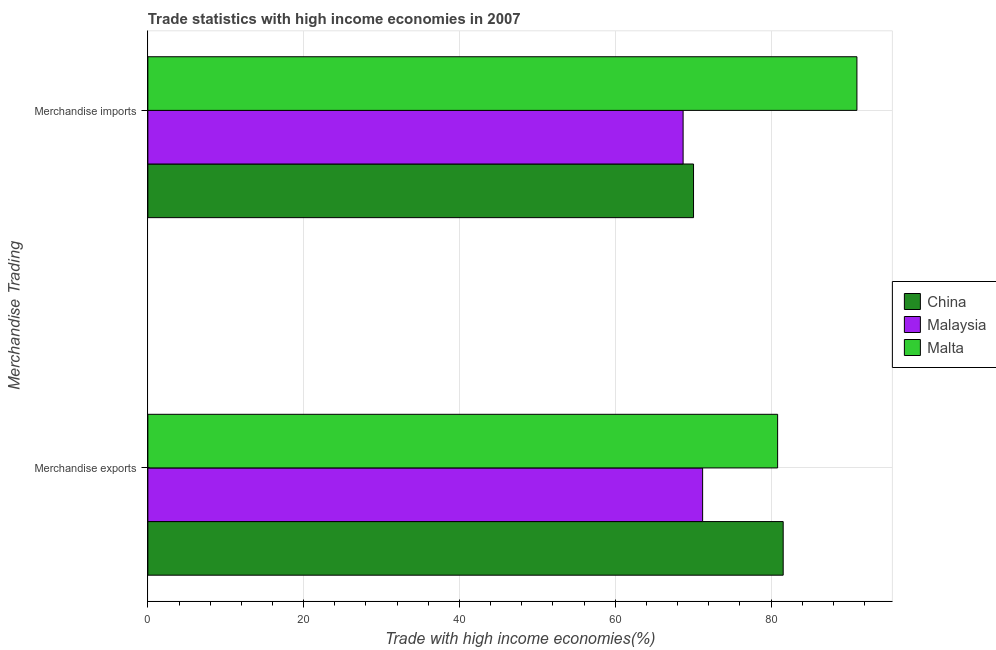How many different coloured bars are there?
Provide a succinct answer. 3. How many bars are there on the 2nd tick from the bottom?
Make the answer very short. 3. What is the merchandise imports in Malta?
Your response must be concise. 91.03. Across all countries, what is the maximum merchandise exports?
Offer a terse response. 81.56. Across all countries, what is the minimum merchandise imports?
Give a very brief answer. 68.71. In which country was the merchandise exports minimum?
Offer a very short reply. Malaysia. What is the total merchandise imports in the graph?
Provide a succinct answer. 229.79. What is the difference between the merchandise imports in Malaysia and that in Malta?
Provide a succinct answer. -22.31. What is the difference between the merchandise exports in Malaysia and the merchandise imports in Malta?
Your answer should be very brief. -19.81. What is the average merchandise imports per country?
Your answer should be very brief. 76.6. What is the difference between the merchandise imports and merchandise exports in China?
Provide a short and direct response. -11.51. What is the ratio of the merchandise exports in Malaysia to that in China?
Provide a succinct answer. 0.87. Is the merchandise imports in Malaysia less than that in China?
Offer a terse response. Yes. In how many countries, is the merchandise exports greater than the average merchandise exports taken over all countries?
Your answer should be very brief. 2. What does the 1st bar from the top in Merchandise imports represents?
Give a very brief answer. Malta. What does the 3rd bar from the bottom in Merchandise exports represents?
Offer a terse response. Malta. How many countries are there in the graph?
Your answer should be very brief. 3. What is the difference between two consecutive major ticks on the X-axis?
Provide a short and direct response. 20. Are the values on the major ticks of X-axis written in scientific E-notation?
Provide a succinct answer. No. Does the graph contain grids?
Your answer should be compact. Yes. How many legend labels are there?
Give a very brief answer. 3. What is the title of the graph?
Provide a short and direct response. Trade statistics with high income economies in 2007. Does "Iceland" appear as one of the legend labels in the graph?
Give a very brief answer. No. What is the label or title of the X-axis?
Your answer should be compact. Trade with high income economies(%). What is the label or title of the Y-axis?
Your response must be concise. Merchandise Trading. What is the Trade with high income economies(%) of China in Merchandise exports?
Give a very brief answer. 81.56. What is the Trade with high income economies(%) of Malaysia in Merchandise exports?
Your answer should be compact. 71.22. What is the Trade with high income economies(%) of Malta in Merchandise exports?
Ensure brevity in your answer.  80.85. What is the Trade with high income economies(%) of China in Merchandise imports?
Offer a terse response. 70.05. What is the Trade with high income economies(%) of Malaysia in Merchandise imports?
Give a very brief answer. 68.71. What is the Trade with high income economies(%) of Malta in Merchandise imports?
Provide a short and direct response. 91.03. Across all Merchandise Trading, what is the maximum Trade with high income economies(%) in China?
Make the answer very short. 81.56. Across all Merchandise Trading, what is the maximum Trade with high income economies(%) of Malaysia?
Give a very brief answer. 71.22. Across all Merchandise Trading, what is the maximum Trade with high income economies(%) in Malta?
Your response must be concise. 91.03. Across all Merchandise Trading, what is the minimum Trade with high income economies(%) in China?
Offer a very short reply. 70.05. Across all Merchandise Trading, what is the minimum Trade with high income economies(%) in Malaysia?
Ensure brevity in your answer.  68.71. Across all Merchandise Trading, what is the minimum Trade with high income economies(%) in Malta?
Your response must be concise. 80.85. What is the total Trade with high income economies(%) in China in the graph?
Your answer should be compact. 151.61. What is the total Trade with high income economies(%) in Malaysia in the graph?
Offer a terse response. 139.93. What is the total Trade with high income economies(%) of Malta in the graph?
Your answer should be very brief. 171.87. What is the difference between the Trade with high income economies(%) in China in Merchandise exports and that in Merchandise imports?
Your answer should be very brief. 11.51. What is the difference between the Trade with high income economies(%) of Malaysia in Merchandise exports and that in Merchandise imports?
Keep it short and to the point. 2.5. What is the difference between the Trade with high income economies(%) in Malta in Merchandise exports and that in Merchandise imports?
Your answer should be very brief. -10.18. What is the difference between the Trade with high income economies(%) of China in Merchandise exports and the Trade with high income economies(%) of Malaysia in Merchandise imports?
Your answer should be very brief. 12.85. What is the difference between the Trade with high income economies(%) in China in Merchandise exports and the Trade with high income economies(%) in Malta in Merchandise imports?
Your answer should be very brief. -9.46. What is the difference between the Trade with high income economies(%) in Malaysia in Merchandise exports and the Trade with high income economies(%) in Malta in Merchandise imports?
Offer a very short reply. -19.81. What is the average Trade with high income economies(%) of China per Merchandise Trading?
Provide a short and direct response. 75.81. What is the average Trade with high income economies(%) of Malaysia per Merchandise Trading?
Keep it short and to the point. 69.97. What is the average Trade with high income economies(%) of Malta per Merchandise Trading?
Offer a very short reply. 85.94. What is the difference between the Trade with high income economies(%) in China and Trade with high income economies(%) in Malaysia in Merchandise exports?
Offer a terse response. 10.34. What is the difference between the Trade with high income economies(%) of China and Trade with high income economies(%) of Malta in Merchandise exports?
Offer a very short reply. 0.71. What is the difference between the Trade with high income economies(%) in Malaysia and Trade with high income economies(%) in Malta in Merchandise exports?
Provide a succinct answer. -9.63. What is the difference between the Trade with high income economies(%) in China and Trade with high income economies(%) in Malaysia in Merchandise imports?
Keep it short and to the point. 1.34. What is the difference between the Trade with high income economies(%) in China and Trade with high income economies(%) in Malta in Merchandise imports?
Ensure brevity in your answer.  -20.97. What is the difference between the Trade with high income economies(%) in Malaysia and Trade with high income economies(%) in Malta in Merchandise imports?
Your answer should be compact. -22.31. What is the ratio of the Trade with high income economies(%) of China in Merchandise exports to that in Merchandise imports?
Keep it short and to the point. 1.16. What is the ratio of the Trade with high income economies(%) in Malaysia in Merchandise exports to that in Merchandise imports?
Your response must be concise. 1.04. What is the ratio of the Trade with high income economies(%) in Malta in Merchandise exports to that in Merchandise imports?
Provide a succinct answer. 0.89. What is the difference between the highest and the second highest Trade with high income economies(%) of China?
Your response must be concise. 11.51. What is the difference between the highest and the second highest Trade with high income economies(%) of Malaysia?
Ensure brevity in your answer.  2.5. What is the difference between the highest and the second highest Trade with high income economies(%) in Malta?
Provide a short and direct response. 10.18. What is the difference between the highest and the lowest Trade with high income economies(%) of China?
Give a very brief answer. 11.51. What is the difference between the highest and the lowest Trade with high income economies(%) in Malaysia?
Offer a very short reply. 2.5. What is the difference between the highest and the lowest Trade with high income economies(%) of Malta?
Your response must be concise. 10.18. 